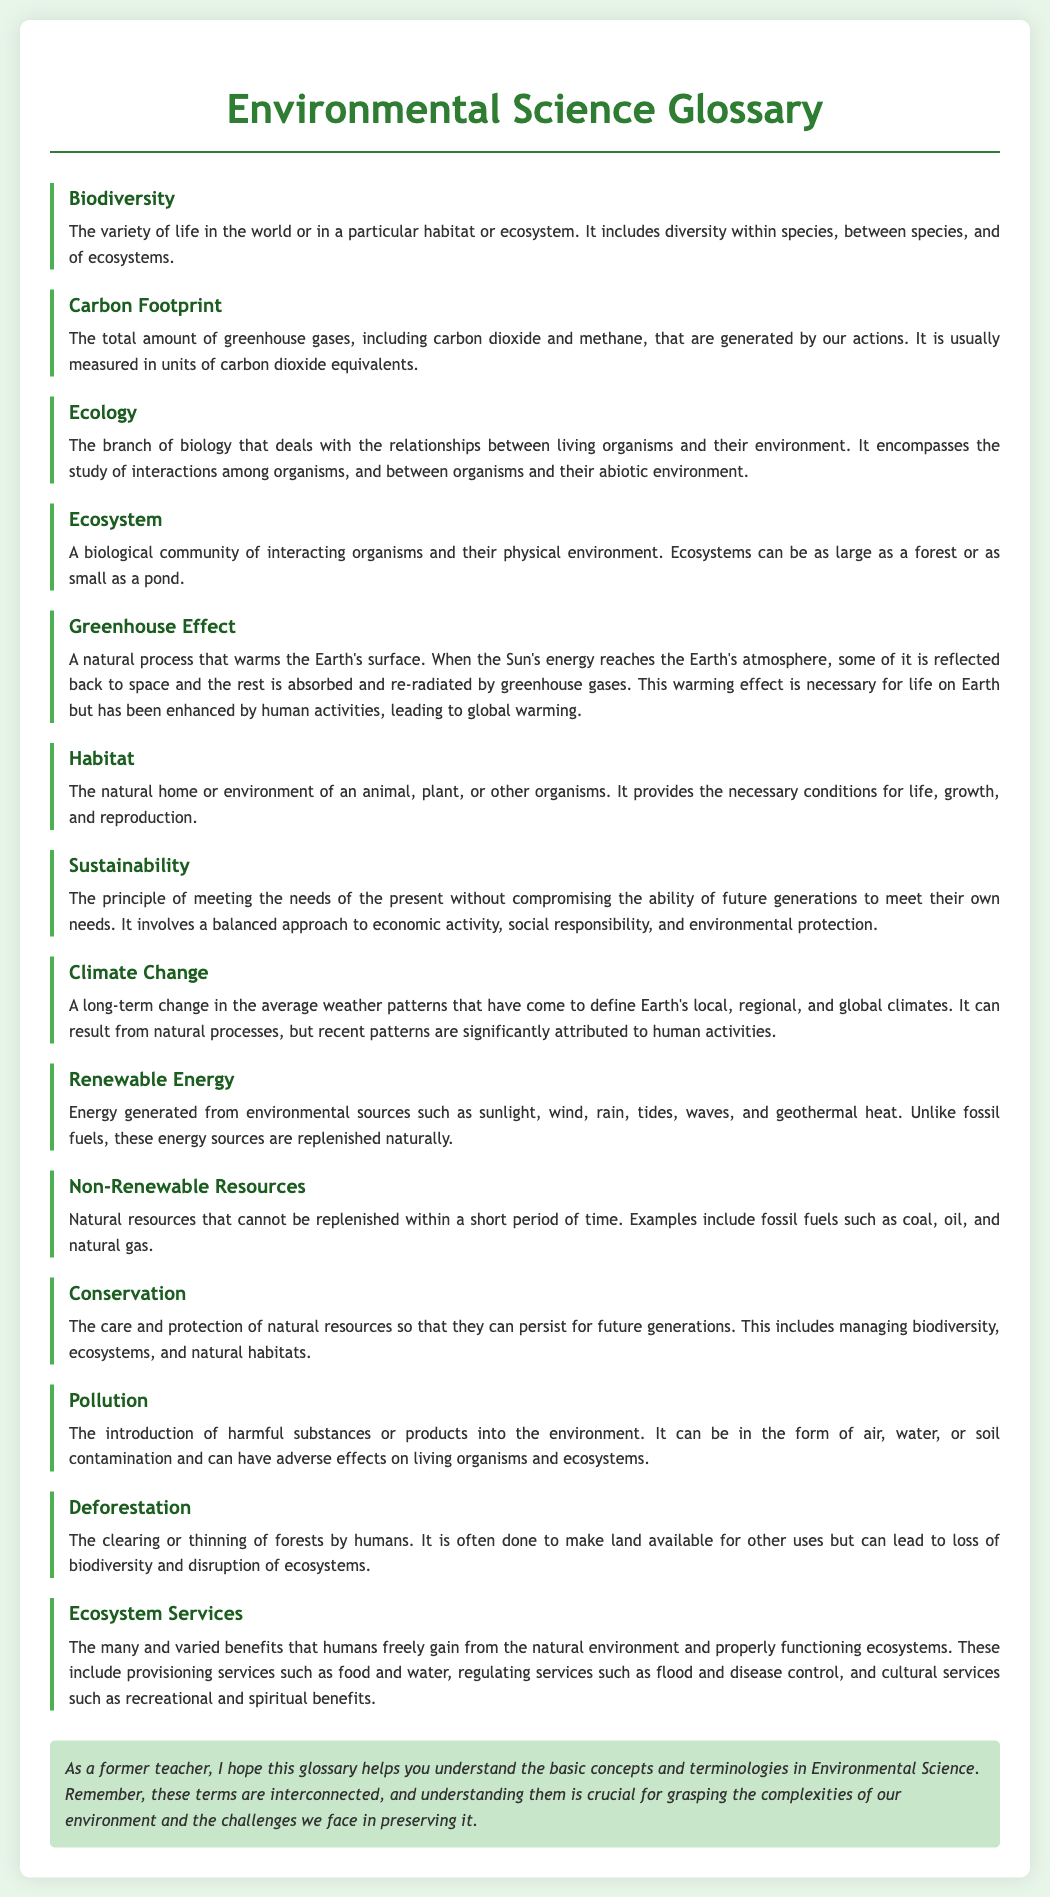What is biodiversity? Biodiversity refers to the variety of life in the world or in a particular habitat or ecosystem, including diversity within species, between species, and of ecosystems.
Answer: The variety of life What does carbon footprint measure? Carbon footprint measures the total amount of greenhouse gases generated by our actions, usually in carbon dioxide equivalents.
Answer: Greenhouse gases What is an ecosystem? An ecosystem is a biological community of interacting organisms and their physical environment, which can vary in size.
Answer: Interacting organisms and environment What effect does human activity have on the Greenhouse Effect? Human activity has enhanced the natural Greenhouse Effect, leading to global warming.
Answer: Global warming Name one example of a non-renewable resource. A non-renewable resource is one that cannot be replenished within a short period, such as fossil fuels.
Answer: Fossil fuels What is the purpose of conservation in environmental science? The purpose of conservation is to care for and protect natural resources to ensure their persistence for future generations.
Answer: Care and protection What is the definition of habitat? A habitat is the natural home or environment of an animal, plant, or other organisms.
Answer: Natural home List one benefit of ecosystem services. Ecosystem services provide many benefits, including provisioning services, regulating services, and cultural services.
Answer: Food and water 